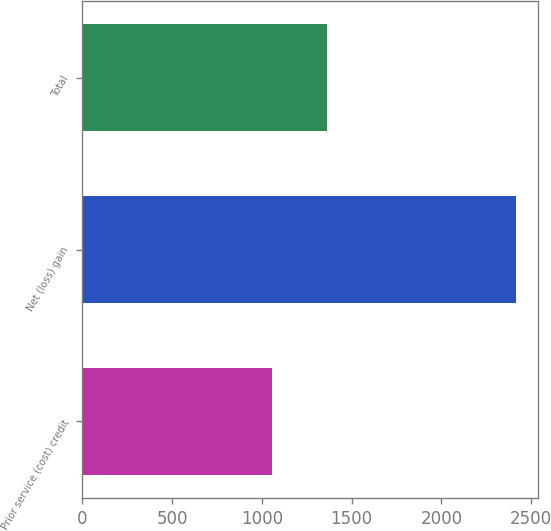<chart> <loc_0><loc_0><loc_500><loc_500><bar_chart><fcel>Prior service (cost) credit<fcel>Net (loss) gain<fcel>Total<nl><fcel>1054<fcel>2417<fcel>1363<nl></chart> 